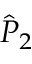Convert formula to latex. <formula><loc_0><loc_0><loc_500><loc_500>{ \hat { P } } _ { 2 }</formula> 